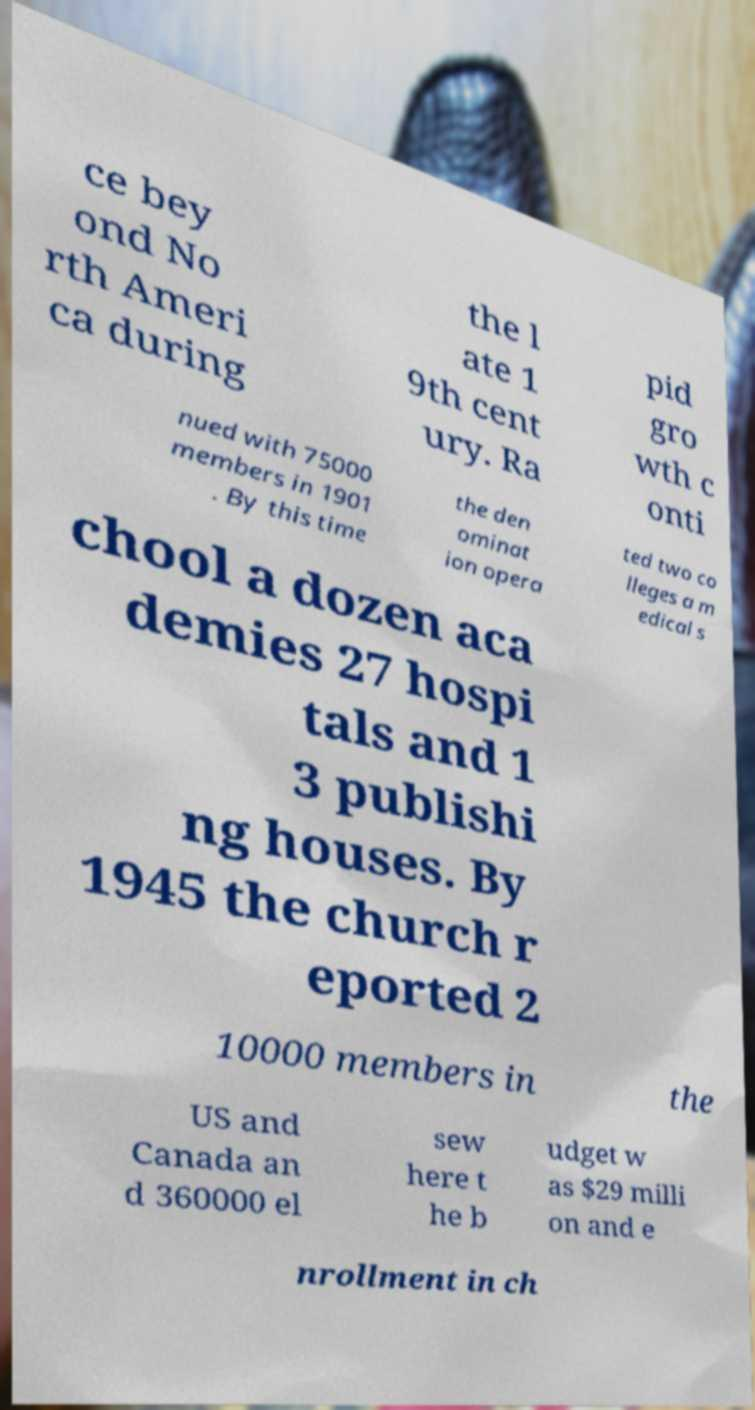Can you read and provide the text displayed in the image?This photo seems to have some interesting text. Can you extract and type it out for me? ce bey ond No rth Ameri ca during the l ate 1 9th cent ury. Ra pid gro wth c onti nued with 75000 members in 1901 . By this time the den ominat ion opera ted two co lleges a m edical s chool a dozen aca demies 27 hospi tals and 1 3 publishi ng houses. By 1945 the church r eported 2 10000 members in the US and Canada an d 360000 el sew here t he b udget w as $29 milli on and e nrollment in ch 